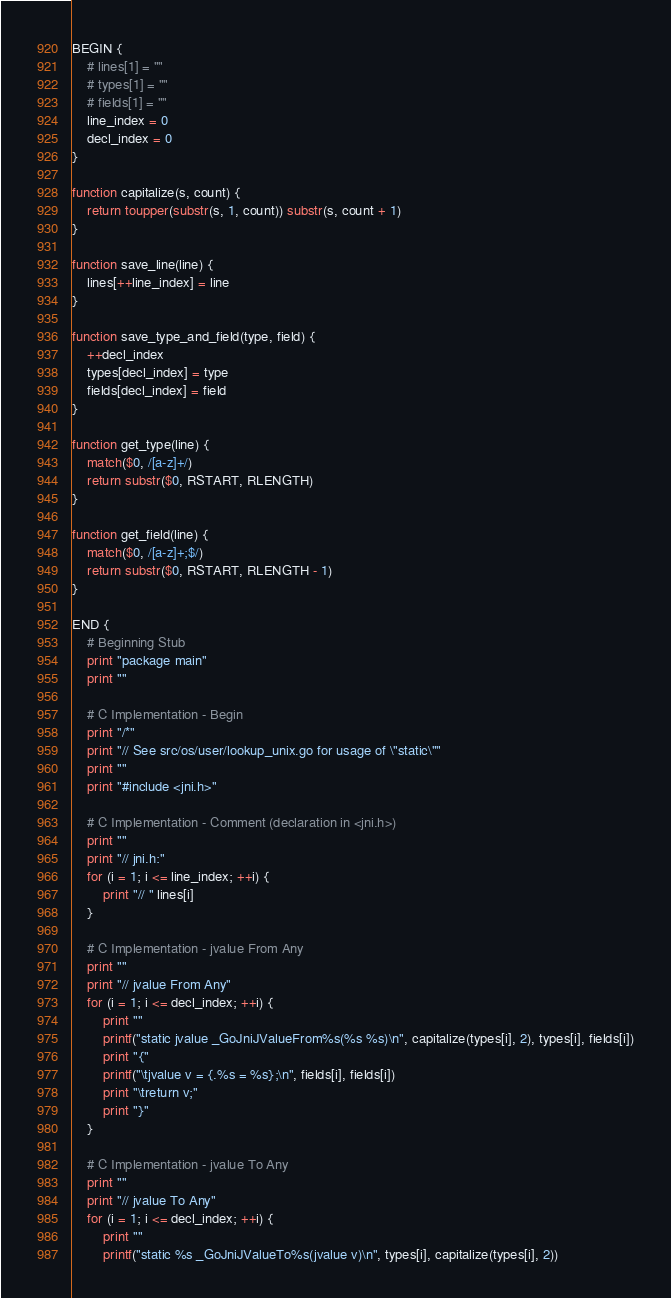<code> <loc_0><loc_0><loc_500><loc_500><_Awk_>BEGIN {
	# lines[1] = ""
	# types[1] = ""
	# fields[1] = ""
	line_index = 0
	decl_index = 0
}

function capitalize(s, count) {
	return toupper(substr(s, 1, count)) substr(s, count + 1)
}

function save_line(line) {
	lines[++line_index] = line
}

function save_type_and_field(type, field) {
	++decl_index
	types[decl_index] = type
	fields[decl_index] = field
}

function get_type(line) {
	match($0, /[a-z]+/)
	return substr($0, RSTART, RLENGTH)
}

function get_field(line) {
	match($0, /[a-z]+;$/)
	return substr($0, RSTART, RLENGTH - 1)
}

END {
	# Beginning Stub
	print "package main"
	print ""

	# C Implementation - Begin
	print "/*"
	print "// See src/os/user/lookup_unix.go for usage of \"static\""
	print ""
	print "#include <jni.h>"

	# C Implementation - Comment (declaration in <jni.h>)
	print ""
	print "// jni.h:"
	for (i = 1; i <= line_index; ++i) {
		print "// " lines[i]
	}

	# C Implementation - jvalue From Any
	print ""
	print "// jvalue From Any"
	for (i = 1; i <= decl_index; ++i) {
		print ""
		printf("static jvalue _GoJniJValueFrom%s(%s %s)\n", capitalize(types[i], 2), types[i], fields[i])
		print "{"
		printf("\tjvalue v = {.%s = %s};\n", fields[i], fields[i])
		print "\treturn v;"
		print "}"
	}

	# C Implementation - jvalue To Any
	print ""
	print "// jvalue To Any"
	for (i = 1; i <= decl_index; ++i) {
		print ""
		printf("static %s _GoJniJValueTo%s(jvalue v)\n", types[i], capitalize(types[i], 2))</code> 